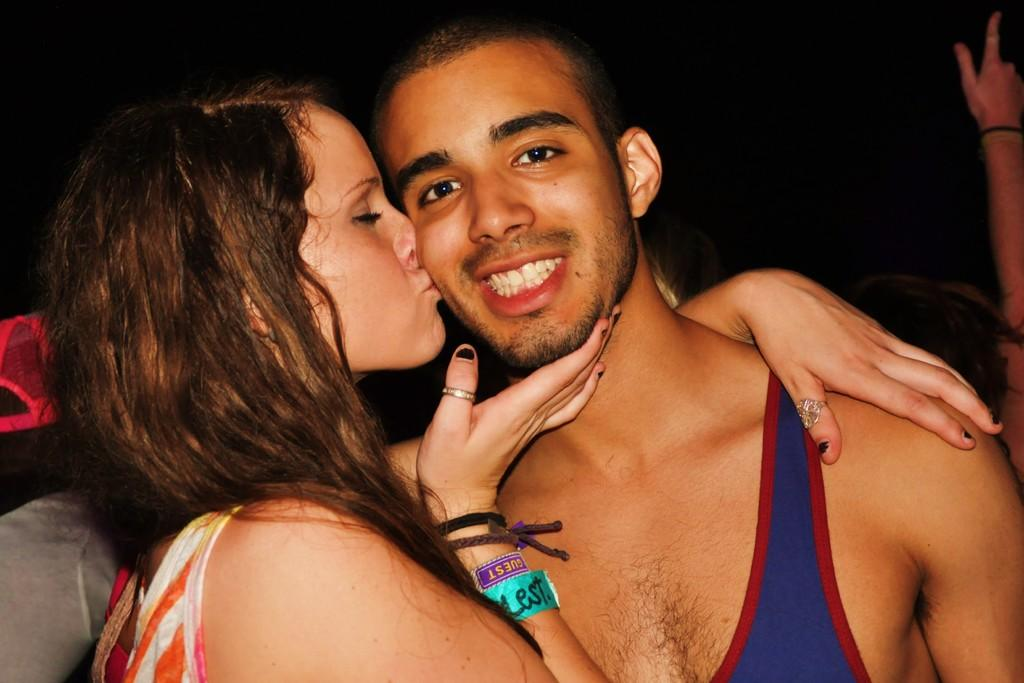Who is present in the image? There is a woman in the image. What is the woman doing in the image? The woman is kissing a man. How is the man positioned in relation to the woman? The man is standing beside the woman. What can be observed about the lighting in the image? The background of the image is dark. What type of engine can be seen in the image? There is no engine present in the image. How many mittens are visible in the image? There are no mittens present in the image. 